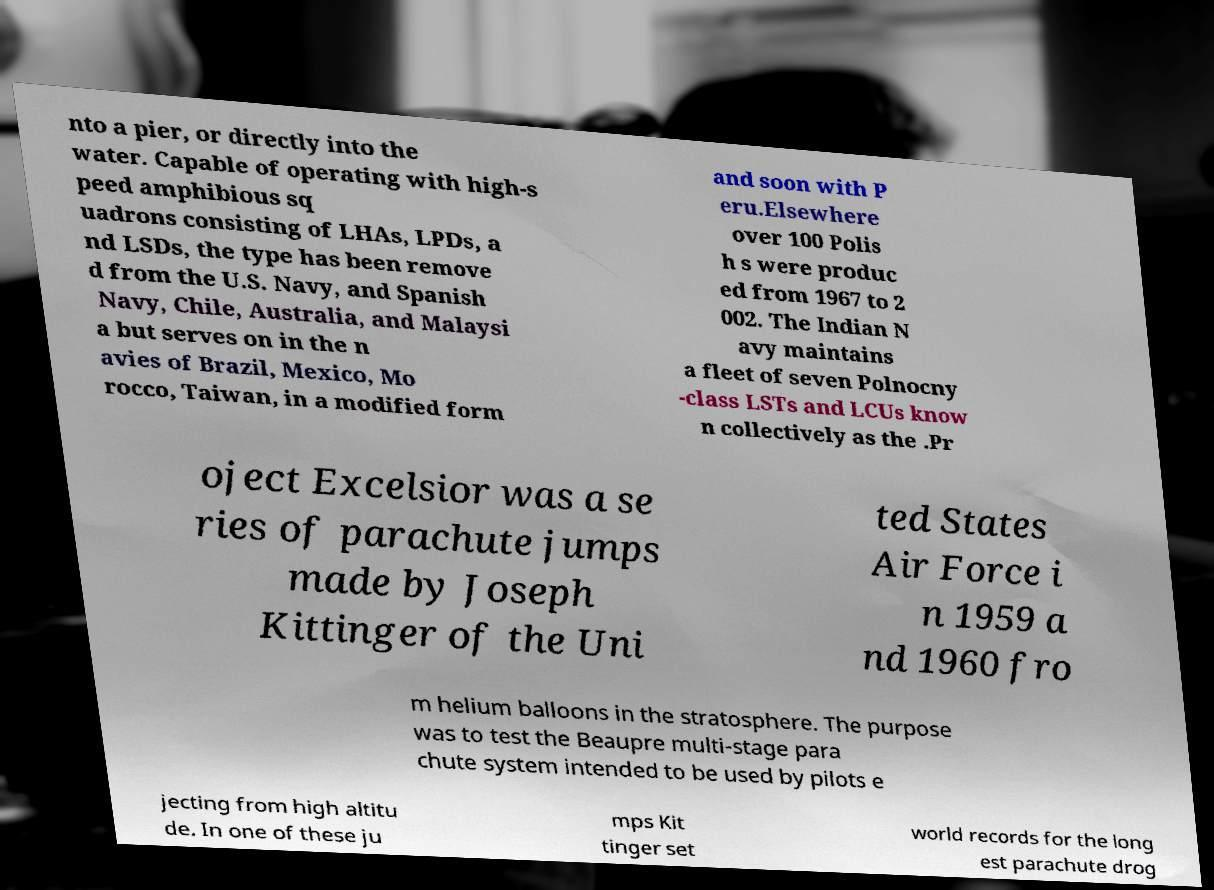Can you read and provide the text displayed in the image?This photo seems to have some interesting text. Can you extract and type it out for me? nto a pier, or directly into the water. Capable of operating with high-s peed amphibious sq uadrons consisting of LHAs, LPDs, a nd LSDs, the type has been remove d from the U.S. Navy, and Spanish Navy, Chile, Australia, and Malaysi a but serves on in the n avies of Brazil, Mexico, Mo rocco, Taiwan, in a modified form and soon with P eru.Elsewhere over 100 Polis h s were produc ed from 1967 to 2 002. The Indian N avy maintains a fleet of seven Polnocny -class LSTs and LCUs know n collectively as the .Pr oject Excelsior was a se ries of parachute jumps made by Joseph Kittinger of the Uni ted States Air Force i n 1959 a nd 1960 fro m helium balloons in the stratosphere. The purpose was to test the Beaupre multi-stage para chute system intended to be used by pilots e jecting from high altitu de. In one of these ju mps Kit tinger set world records for the long est parachute drog 